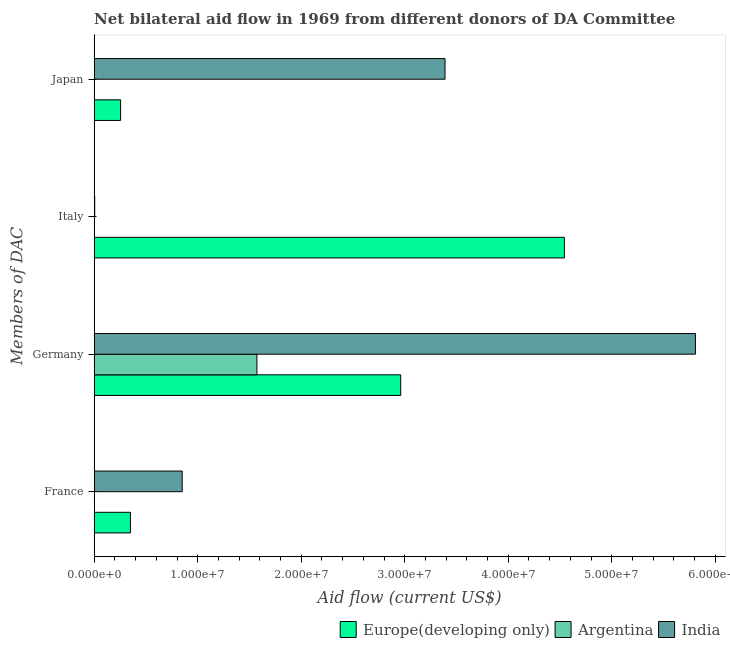Are the number of bars on each tick of the Y-axis equal?
Offer a terse response. No. How many bars are there on the 2nd tick from the top?
Offer a terse response. 2. How many bars are there on the 1st tick from the bottom?
Give a very brief answer. 2. What is the amount of aid given by france in Europe(developing only)?
Your answer should be very brief. 3.50e+06. Across all countries, what is the maximum amount of aid given by france?
Make the answer very short. 8.50e+06. Across all countries, what is the minimum amount of aid given by france?
Your response must be concise. 0. In which country was the amount of aid given by italy maximum?
Ensure brevity in your answer.  Europe(developing only). What is the total amount of aid given by italy in the graph?
Your answer should be compact. 4.55e+07. What is the difference between the amount of aid given by france in Europe(developing only) and that in India?
Your answer should be very brief. -5.00e+06. What is the difference between the amount of aid given by france in India and the amount of aid given by italy in Europe(developing only)?
Your response must be concise. -3.69e+07. What is the difference between the amount of aid given by germany and amount of aid given by italy in Europe(developing only)?
Give a very brief answer. -1.58e+07. What is the ratio of the amount of aid given by japan in Europe(developing only) to that in India?
Ensure brevity in your answer.  0.08. Is the amount of aid given by germany in Europe(developing only) less than that in Argentina?
Your response must be concise. No. Is the difference between the amount of aid given by japan in Europe(developing only) and India greater than the difference between the amount of aid given by germany in Europe(developing only) and India?
Give a very brief answer. No. What is the difference between the highest and the second highest amount of aid given by germany?
Keep it short and to the point. 2.85e+07. What is the difference between the highest and the lowest amount of aid given by japan?
Your answer should be very brief. 3.39e+07. In how many countries, is the amount of aid given by japan greater than the average amount of aid given by japan taken over all countries?
Your response must be concise. 1. Is it the case that in every country, the sum of the amount of aid given by japan and amount of aid given by germany is greater than the sum of amount of aid given by france and amount of aid given by italy?
Provide a succinct answer. No. Is it the case that in every country, the sum of the amount of aid given by france and amount of aid given by germany is greater than the amount of aid given by italy?
Provide a short and direct response. No. How many bars are there?
Make the answer very short. 9. Are all the bars in the graph horizontal?
Offer a very short reply. Yes. How many countries are there in the graph?
Provide a succinct answer. 3. Are the values on the major ticks of X-axis written in scientific E-notation?
Ensure brevity in your answer.  Yes. Where does the legend appear in the graph?
Provide a succinct answer. Bottom right. How many legend labels are there?
Your answer should be compact. 3. How are the legend labels stacked?
Your answer should be compact. Horizontal. What is the title of the graph?
Provide a succinct answer. Net bilateral aid flow in 1969 from different donors of DA Committee. What is the label or title of the X-axis?
Offer a terse response. Aid flow (current US$). What is the label or title of the Y-axis?
Offer a very short reply. Members of DAC. What is the Aid flow (current US$) in Europe(developing only) in France?
Your response must be concise. 3.50e+06. What is the Aid flow (current US$) in India in France?
Make the answer very short. 8.50e+06. What is the Aid flow (current US$) in Europe(developing only) in Germany?
Your response must be concise. 2.96e+07. What is the Aid flow (current US$) in Argentina in Germany?
Provide a short and direct response. 1.57e+07. What is the Aid flow (current US$) in India in Germany?
Your answer should be very brief. 5.81e+07. What is the Aid flow (current US$) in Europe(developing only) in Italy?
Give a very brief answer. 4.54e+07. What is the Aid flow (current US$) in Argentina in Italy?
Ensure brevity in your answer.  0. What is the Aid flow (current US$) of India in Italy?
Your answer should be compact. 5.00e+04. What is the Aid flow (current US$) of Europe(developing only) in Japan?
Offer a terse response. 2.55e+06. What is the Aid flow (current US$) in Argentina in Japan?
Your response must be concise. 0. What is the Aid flow (current US$) of India in Japan?
Your response must be concise. 3.39e+07. Across all Members of DAC, what is the maximum Aid flow (current US$) in Europe(developing only)?
Your answer should be compact. 4.54e+07. Across all Members of DAC, what is the maximum Aid flow (current US$) of Argentina?
Make the answer very short. 1.57e+07. Across all Members of DAC, what is the maximum Aid flow (current US$) of India?
Provide a short and direct response. 5.81e+07. Across all Members of DAC, what is the minimum Aid flow (current US$) in Europe(developing only)?
Offer a terse response. 2.55e+06. Across all Members of DAC, what is the minimum Aid flow (current US$) in Argentina?
Offer a very short reply. 0. What is the total Aid flow (current US$) of Europe(developing only) in the graph?
Ensure brevity in your answer.  8.11e+07. What is the total Aid flow (current US$) of Argentina in the graph?
Your answer should be compact. 1.57e+07. What is the total Aid flow (current US$) of India in the graph?
Offer a terse response. 1.01e+08. What is the difference between the Aid flow (current US$) in Europe(developing only) in France and that in Germany?
Ensure brevity in your answer.  -2.61e+07. What is the difference between the Aid flow (current US$) in India in France and that in Germany?
Offer a very short reply. -4.96e+07. What is the difference between the Aid flow (current US$) of Europe(developing only) in France and that in Italy?
Give a very brief answer. -4.19e+07. What is the difference between the Aid flow (current US$) of India in France and that in Italy?
Give a very brief answer. 8.45e+06. What is the difference between the Aid flow (current US$) in Europe(developing only) in France and that in Japan?
Ensure brevity in your answer.  9.50e+05. What is the difference between the Aid flow (current US$) of India in France and that in Japan?
Offer a terse response. -2.54e+07. What is the difference between the Aid flow (current US$) in Europe(developing only) in Germany and that in Italy?
Ensure brevity in your answer.  -1.58e+07. What is the difference between the Aid flow (current US$) of India in Germany and that in Italy?
Your response must be concise. 5.80e+07. What is the difference between the Aid flow (current US$) of Europe(developing only) in Germany and that in Japan?
Provide a short and direct response. 2.71e+07. What is the difference between the Aid flow (current US$) of India in Germany and that in Japan?
Give a very brief answer. 2.42e+07. What is the difference between the Aid flow (current US$) in Europe(developing only) in Italy and that in Japan?
Give a very brief answer. 4.29e+07. What is the difference between the Aid flow (current US$) in India in Italy and that in Japan?
Keep it short and to the point. -3.38e+07. What is the difference between the Aid flow (current US$) in Europe(developing only) in France and the Aid flow (current US$) in Argentina in Germany?
Give a very brief answer. -1.22e+07. What is the difference between the Aid flow (current US$) of Europe(developing only) in France and the Aid flow (current US$) of India in Germany?
Make the answer very short. -5.46e+07. What is the difference between the Aid flow (current US$) of Europe(developing only) in France and the Aid flow (current US$) of India in Italy?
Your answer should be very brief. 3.45e+06. What is the difference between the Aid flow (current US$) of Europe(developing only) in France and the Aid flow (current US$) of India in Japan?
Keep it short and to the point. -3.04e+07. What is the difference between the Aid flow (current US$) in Europe(developing only) in Germany and the Aid flow (current US$) in India in Italy?
Offer a terse response. 2.96e+07. What is the difference between the Aid flow (current US$) of Argentina in Germany and the Aid flow (current US$) of India in Italy?
Provide a short and direct response. 1.57e+07. What is the difference between the Aid flow (current US$) of Europe(developing only) in Germany and the Aid flow (current US$) of India in Japan?
Offer a terse response. -4.28e+06. What is the difference between the Aid flow (current US$) in Argentina in Germany and the Aid flow (current US$) in India in Japan?
Offer a terse response. -1.82e+07. What is the difference between the Aid flow (current US$) in Europe(developing only) in Italy and the Aid flow (current US$) in India in Japan?
Your answer should be compact. 1.15e+07. What is the average Aid flow (current US$) in Europe(developing only) per Members of DAC?
Make the answer very short. 2.03e+07. What is the average Aid flow (current US$) of Argentina per Members of DAC?
Offer a terse response. 3.93e+06. What is the average Aid flow (current US$) in India per Members of DAC?
Provide a succinct answer. 2.51e+07. What is the difference between the Aid flow (current US$) in Europe(developing only) and Aid flow (current US$) in India in France?
Keep it short and to the point. -5.00e+06. What is the difference between the Aid flow (current US$) in Europe(developing only) and Aid flow (current US$) in Argentina in Germany?
Keep it short and to the point. 1.39e+07. What is the difference between the Aid flow (current US$) of Europe(developing only) and Aid flow (current US$) of India in Germany?
Make the answer very short. -2.85e+07. What is the difference between the Aid flow (current US$) of Argentina and Aid flow (current US$) of India in Germany?
Keep it short and to the point. -4.24e+07. What is the difference between the Aid flow (current US$) in Europe(developing only) and Aid flow (current US$) in India in Italy?
Provide a short and direct response. 4.54e+07. What is the difference between the Aid flow (current US$) of Europe(developing only) and Aid flow (current US$) of India in Japan?
Your response must be concise. -3.13e+07. What is the ratio of the Aid flow (current US$) of Europe(developing only) in France to that in Germany?
Provide a succinct answer. 0.12. What is the ratio of the Aid flow (current US$) in India in France to that in Germany?
Provide a succinct answer. 0.15. What is the ratio of the Aid flow (current US$) of Europe(developing only) in France to that in Italy?
Provide a short and direct response. 0.08. What is the ratio of the Aid flow (current US$) in India in France to that in Italy?
Provide a succinct answer. 170. What is the ratio of the Aid flow (current US$) of Europe(developing only) in France to that in Japan?
Make the answer very short. 1.37. What is the ratio of the Aid flow (current US$) of India in France to that in Japan?
Make the answer very short. 0.25. What is the ratio of the Aid flow (current US$) in Europe(developing only) in Germany to that in Italy?
Your answer should be very brief. 0.65. What is the ratio of the Aid flow (current US$) in India in Germany to that in Italy?
Your answer should be very brief. 1161.6. What is the ratio of the Aid flow (current US$) of Europe(developing only) in Germany to that in Japan?
Provide a short and direct response. 11.61. What is the ratio of the Aid flow (current US$) in India in Germany to that in Japan?
Ensure brevity in your answer.  1.71. What is the ratio of the Aid flow (current US$) in Europe(developing only) in Italy to that in Japan?
Your answer should be compact. 17.81. What is the ratio of the Aid flow (current US$) in India in Italy to that in Japan?
Give a very brief answer. 0. What is the difference between the highest and the second highest Aid flow (current US$) of Europe(developing only)?
Keep it short and to the point. 1.58e+07. What is the difference between the highest and the second highest Aid flow (current US$) in India?
Provide a short and direct response. 2.42e+07. What is the difference between the highest and the lowest Aid flow (current US$) in Europe(developing only)?
Your answer should be compact. 4.29e+07. What is the difference between the highest and the lowest Aid flow (current US$) in Argentina?
Give a very brief answer. 1.57e+07. What is the difference between the highest and the lowest Aid flow (current US$) in India?
Provide a succinct answer. 5.80e+07. 